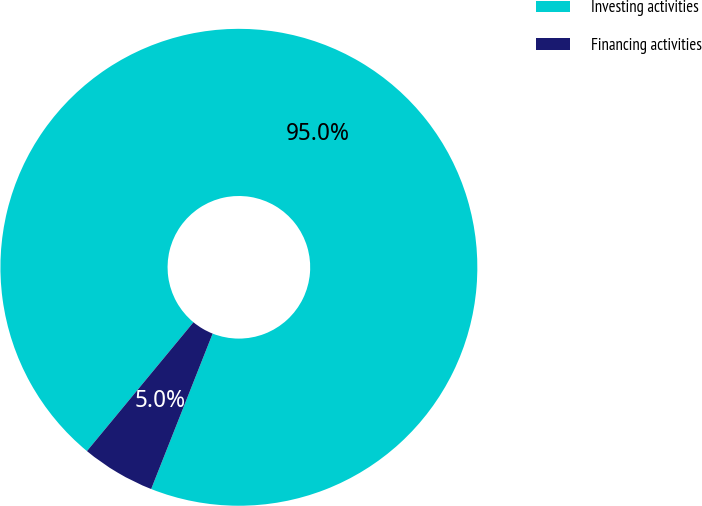Convert chart. <chart><loc_0><loc_0><loc_500><loc_500><pie_chart><fcel>Investing activities<fcel>Financing activities<nl><fcel>95.0%<fcel>5.0%<nl></chart> 